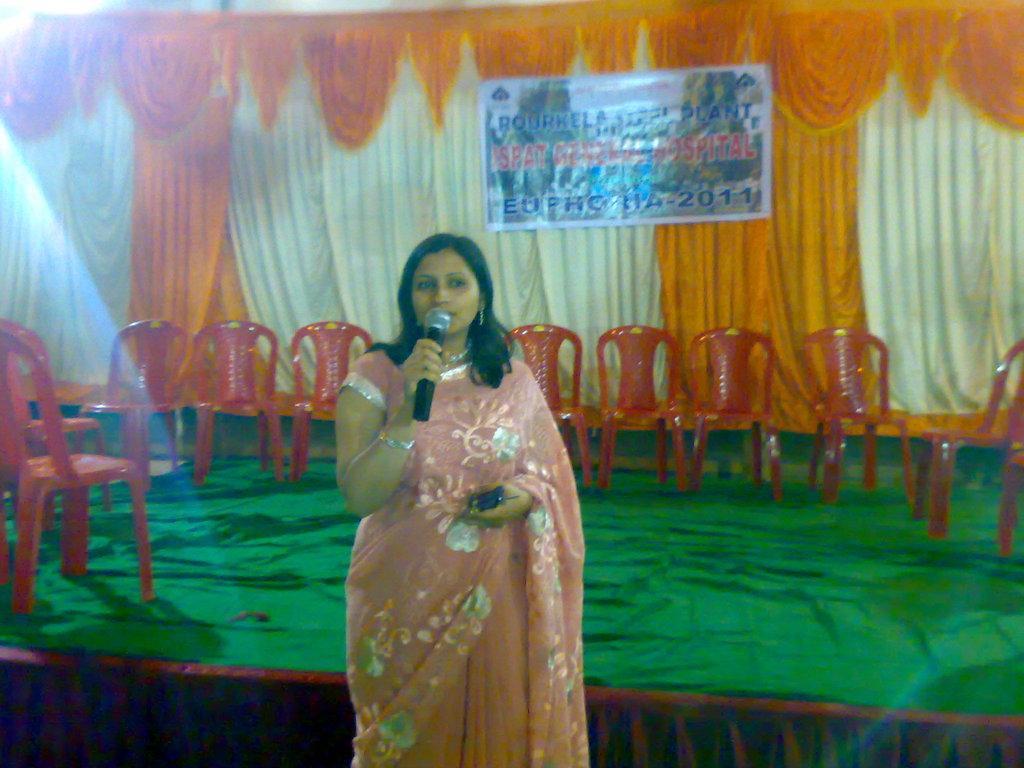In one or two sentences, can you explain what this image depicts? In this image there is a woman standing in the center holding a mic in her hand and a phone on the other hand. In the background there are chairs which are empty and the carpet which is green in colour and a curtains off white and orange and a banner. 